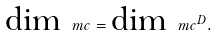<formula> <loc_0><loc_0><loc_500><loc_500>\text {dim} \, \ m c = \text {dim} \, \ m c ^ { D } .</formula> 